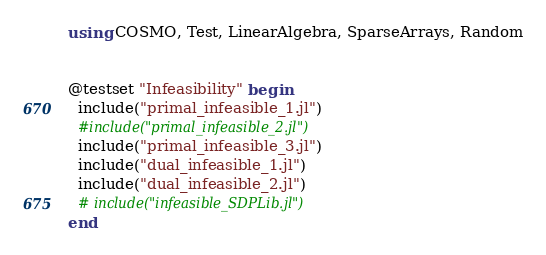<code> <loc_0><loc_0><loc_500><loc_500><_Julia_>using COSMO, Test, LinearAlgebra, SparseArrays, Random


@testset "Infeasibility" begin
  include("primal_infeasible_1.jl")
  #include("primal_infeasible_2.jl")
  include("primal_infeasible_3.jl")
  include("dual_infeasible_1.jl")
  include("dual_infeasible_2.jl")
  # include("infeasible_SDPLib.jl")
end
</code> 